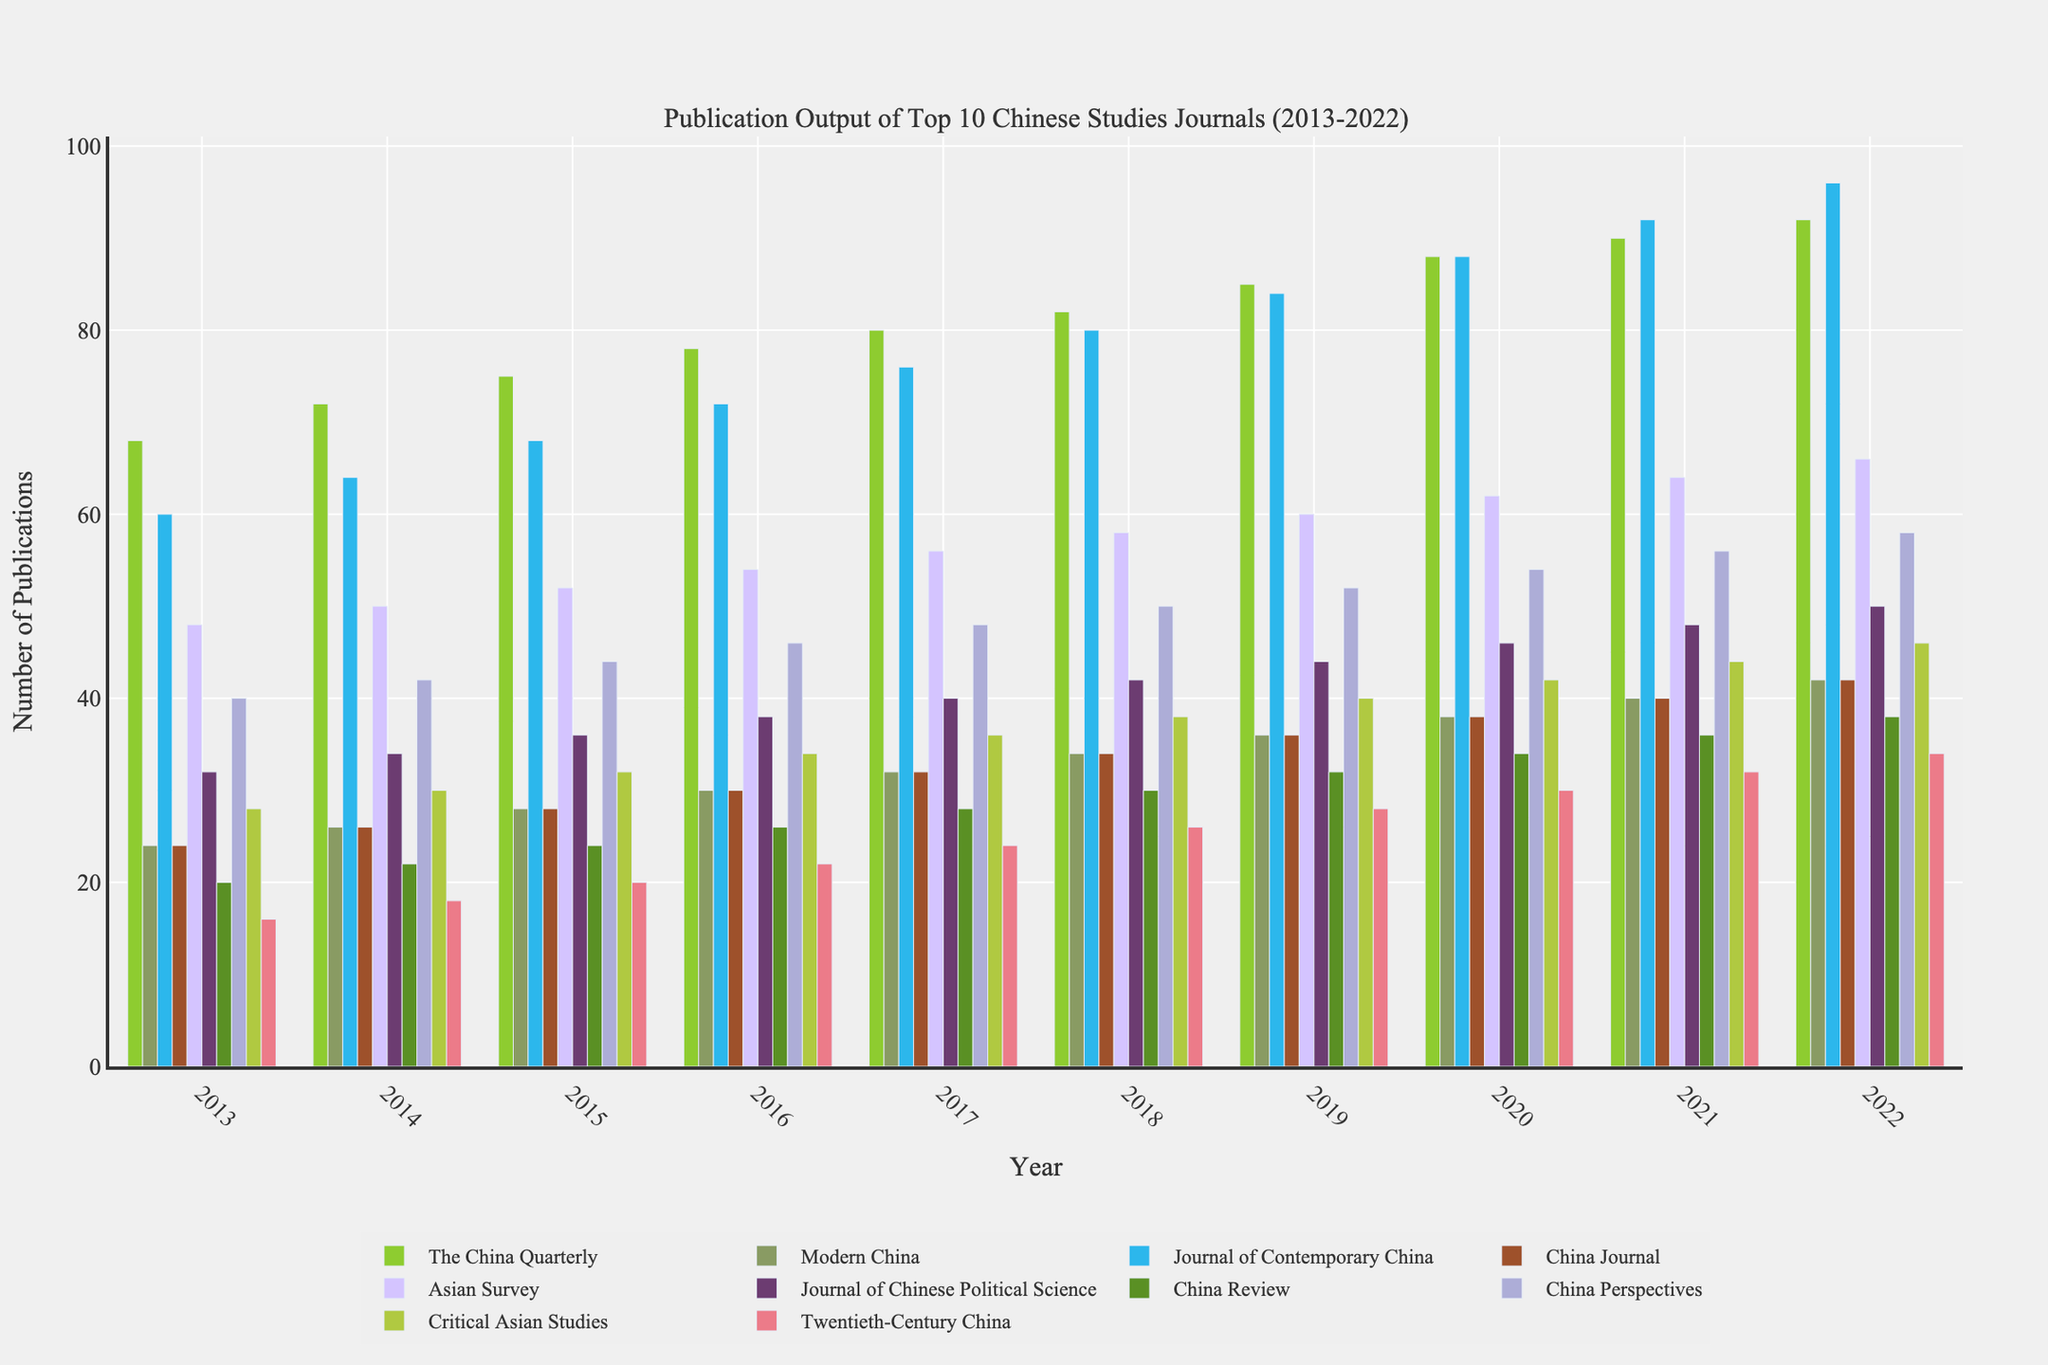What's the trend of publication output for "The China Quarterly" over the decade? To observe the trend of "The China Quarterly," look at the heights of the bars associated with this journal from 2013 to 2022. The bars increase consistently each year, indicating a continuous upwards trend in publication output.
Answer: Increasing Which journal had the highest publication output in 2015? To identify the journal with the highest publication output in 2015, compare the heights of the bars for each journal in the year 2015. "Journal of Contemporary China" has the highest bar among all, indicating it had the highest publication output.
Answer: Journal of Contemporary China What is the sum of publications for "Twentieth-Century China" from 2018 to 2022? To find the sum, add the publication numbers for "Twentieth-Century China" for the years 2018 to 2022. The values are 26 (2018) + 28 (2019) + 30 (2020) + 32 (2021) + 34 (2022) = 150.
Answer: 150 Which journals have identical publication output in 2020? To determine which journals have identical publication outputs in 2020, look for bars of equal heights in the year 2020. "Modern China" and "China Journal" both have 38 publications.
Answer: Modern China, China Journal What is the average publication output of "Asian Survey" over the decade? To compute the average, sum the publication numbers for "Asian Survey" from 2013 to 2022 and divide by the number of years (10). The sum is 48 + 50 + 52 + 54 + 56 + 58 + 60 + 62 + 64 + 66 = 570. Therefore, the average is 570 / 10 = 57.
Answer: 57 Which journal saw the largest increase in publications between 2013 and 2022? To find the journal with the largest increase in publications, calculate the difference in publication numbers between 2022 and 2013 for each journal. "Journal of Contemporary China" increased from 60 (2013) to 96 (2022), an increase of 36, which is the largest among all journals.
Answer: Journal of Contemporary China How many more publications did "China Perspectives" have compared to "China Review" in 2022? To determine the difference, subtract the publications for "China Review" from "China Perspectives" in 2022. "China Perspectives" had 58 publications, and "China Review" had 38, so 58 - 38 = 20.
Answer: 20 What is the median publication output for "Critical Asian Studies" over the decade? To find the median, list the publication outputs for "Critical Asian Studies" from 2013 to 2022 and identify the middle value(s). The values are 28, 30, 32, 34, 36, 38, 40, 42, 44, 46. The median is the average of the 5th and 6th values, (36 + 38) / 2 = 37.
Answer: 37 Which color is used to represent "Modern China" in the plot? To determine the color representing "Modern China," observe the visual attributes of the bars associated with this journal. The bars are colored blue in the provided figure.
Answer: Blue 